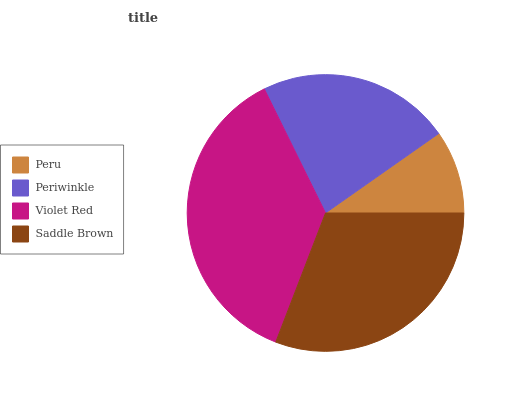Is Peru the minimum?
Answer yes or no. Yes. Is Violet Red the maximum?
Answer yes or no. Yes. Is Periwinkle the minimum?
Answer yes or no. No. Is Periwinkle the maximum?
Answer yes or no. No. Is Periwinkle greater than Peru?
Answer yes or no. Yes. Is Peru less than Periwinkle?
Answer yes or no. Yes. Is Peru greater than Periwinkle?
Answer yes or no. No. Is Periwinkle less than Peru?
Answer yes or no. No. Is Saddle Brown the high median?
Answer yes or no. Yes. Is Periwinkle the low median?
Answer yes or no. Yes. Is Periwinkle the high median?
Answer yes or no. No. Is Saddle Brown the low median?
Answer yes or no. No. 